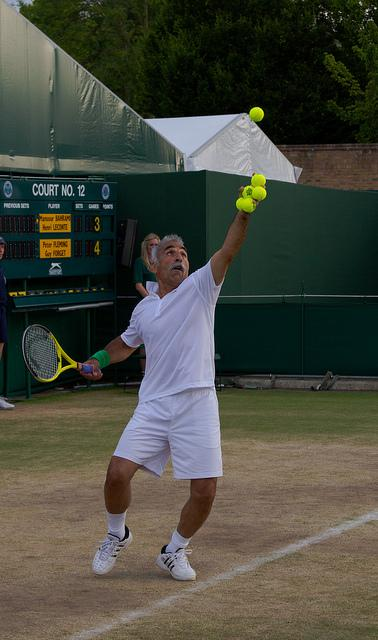Why is he holding several tennis balls? practicing 